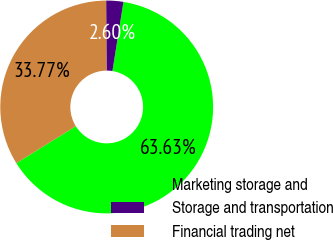<chart> <loc_0><loc_0><loc_500><loc_500><pie_chart><fcel>Marketing storage and<fcel>Storage and transportation<fcel>Financial trading net<nl><fcel>63.64%<fcel>2.6%<fcel>33.77%<nl></chart> 